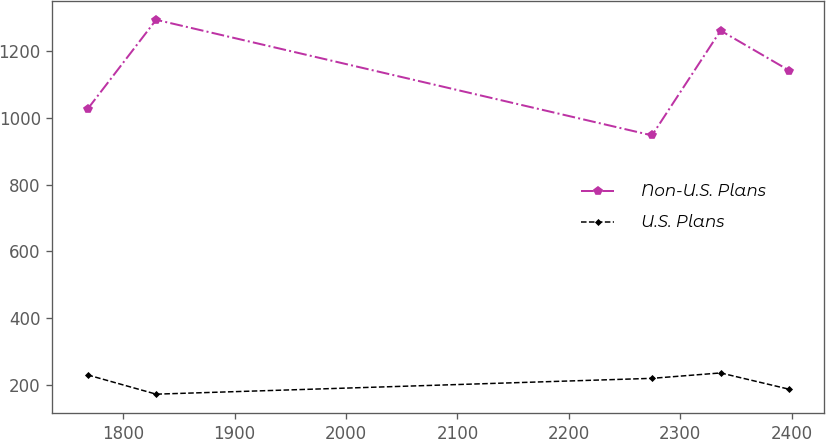Convert chart to OTSL. <chart><loc_0><loc_0><loc_500><loc_500><line_chart><ecel><fcel>Non-U.S. Plans<fcel>U.S. Plans<nl><fcel>1767.95<fcel>1025.86<fcel>229.37<nl><fcel>1829.55<fcel>1293.71<fcel>171.66<nl><fcel>2274.65<fcel>947.18<fcel>219.09<nl><fcel>2336.25<fcel>1261.28<fcel>235.26<nl><fcel>2397.85<fcel>1141.63<fcel>186.41<nl></chart> 